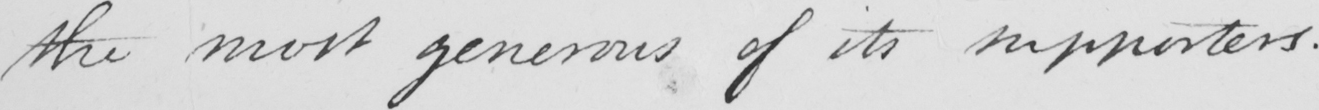Can you tell me what this handwritten text says? the most generous of its supporters .  _ 